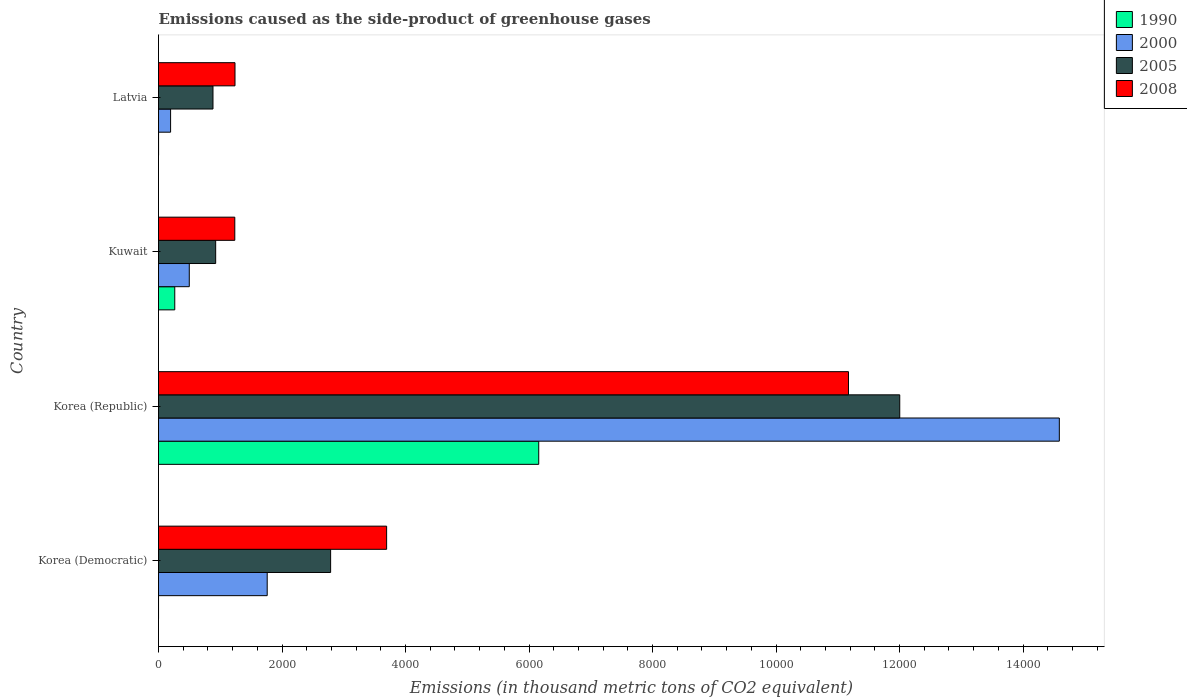How many groups of bars are there?
Ensure brevity in your answer.  4. Are the number of bars per tick equal to the number of legend labels?
Offer a terse response. Yes. Are the number of bars on each tick of the Y-axis equal?
Offer a terse response. Yes. What is the label of the 3rd group of bars from the top?
Keep it short and to the point. Korea (Republic). What is the emissions caused as the side-product of greenhouse gases in 1990 in Korea (Republic)?
Keep it short and to the point. 6157.2. Across all countries, what is the maximum emissions caused as the side-product of greenhouse gases in 2008?
Provide a succinct answer. 1.12e+04. Across all countries, what is the minimum emissions caused as the side-product of greenhouse gases in 2005?
Provide a short and direct response. 882.1. In which country was the emissions caused as the side-product of greenhouse gases in 2008 minimum?
Offer a very short reply. Kuwait. What is the total emissions caused as the side-product of greenhouse gases in 2000 in the graph?
Offer a very short reply. 1.70e+04. What is the difference between the emissions caused as the side-product of greenhouse gases in 2000 in Korea (Democratic) and that in Korea (Republic)?
Your response must be concise. -1.28e+04. What is the difference between the emissions caused as the side-product of greenhouse gases in 2000 in Kuwait and the emissions caused as the side-product of greenhouse gases in 2005 in Korea (Republic)?
Keep it short and to the point. -1.15e+04. What is the average emissions caused as the side-product of greenhouse gases in 2005 per country?
Make the answer very short. 4149.52. What is the difference between the emissions caused as the side-product of greenhouse gases in 2005 and emissions caused as the side-product of greenhouse gases in 2008 in Korea (Republic)?
Your answer should be very brief. 830.4. In how many countries, is the emissions caused as the side-product of greenhouse gases in 1990 greater than 10400 thousand metric tons?
Give a very brief answer. 0. What is the ratio of the emissions caused as the side-product of greenhouse gases in 1990 in Korea (Republic) to that in Latvia?
Give a very brief answer. 7696.5. Is the difference between the emissions caused as the side-product of greenhouse gases in 2005 in Korea (Democratic) and Korea (Republic) greater than the difference between the emissions caused as the side-product of greenhouse gases in 2008 in Korea (Democratic) and Korea (Republic)?
Keep it short and to the point. No. What is the difference between the highest and the second highest emissions caused as the side-product of greenhouse gases in 2005?
Offer a terse response. 9216.2. What is the difference between the highest and the lowest emissions caused as the side-product of greenhouse gases in 2000?
Keep it short and to the point. 1.44e+04. In how many countries, is the emissions caused as the side-product of greenhouse gases in 1990 greater than the average emissions caused as the side-product of greenhouse gases in 1990 taken over all countries?
Your answer should be compact. 1. Is the sum of the emissions caused as the side-product of greenhouse gases in 2005 in Korea (Republic) and Kuwait greater than the maximum emissions caused as the side-product of greenhouse gases in 1990 across all countries?
Offer a terse response. Yes. Is it the case that in every country, the sum of the emissions caused as the side-product of greenhouse gases in 2005 and emissions caused as the side-product of greenhouse gases in 2008 is greater than the sum of emissions caused as the side-product of greenhouse gases in 2000 and emissions caused as the side-product of greenhouse gases in 1990?
Your response must be concise. No. Is it the case that in every country, the sum of the emissions caused as the side-product of greenhouse gases in 1990 and emissions caused as the side-product of greenhouse gases in 2005 is greater than the emissions caused as the side-product of greenhouse gases in 2000?
Your answer should be very brief. Yes. Are all the bars in the graph horizontal?
Your answer should be compact. Yes. How many countries are there in the graph?
Give a very brief answer. 4. Does the graph contain grids?
Provide a succinct answer. No. How many legend labels are there?
Ensure brevity in your answer.  4. What is the title of the graph?
Offer a terse response. Emissions caused as the side-product of greenhouse gases. What is the label or title of the X-axis?
Your answer should be compact. Emissions (in thousand metric tons of CO2 equivalent). What is the label or title of the Y-axis?
Offer a terse response. Country. What is the Emissions (in thousand metric tons of CO2 equivalent) of 1990 in Korea (Democratic)?
Keep it short and to the point. 0.2. What is the Emissions (in thousand metric tons of CO2 equivalent) in 2000 in Korea (Democratic)?
Provide a short and direct response. 1760.1. What is the Emissions (in thousand metric tons of CO2 equivalent) of 2005 in Korea (Democratic)?
Provide a short and direct response. 2787.1. What is the Emissions (in thousand metric tons of CO2 equivalent) of 2008 in Korea (Democratic)?
Keep it short and to the point. 3693.8. What is the Emissions (in thousand metric tons of CO2 equivalent) in 1990 in Korea (Republic)?
Your answer should be very brief. 6157.2. What is the Emissions (in thousand metric tons of CO2 equivalent) of 2000 in Korea (Republic)?
Your answer should be compact. 1.46e+04. What is the Emissions (in thousand metric tons of CO2 equivalent) in 2005 in Korea (Republic)?
Keep it short and to the point. 1.20e+04. What is the Emissions (in thousand metric tons of CO2 equivalent) in 2008 in Korea (Republic)?
Your response must be concise. 1.12e+04. What is the Emissions (in thousand metric tons of CO2 equivalent) in 1990 in Kuwait?
Your answer should be very brief. 263.1. What is the Emissions (in thousand metric tons of CO2 equivalent) of 2000 in Kuwait?
Keep it short and to the point. 498.2. What is the Emissions (in thousand metric tons of CO2 equivalent) of 2005 in Kuwait?
Ensure brevity in your answer.  925.6. What is the Emissions (in thousand metric tons of CO2 equivalent) in 2008 in Kuwait?
Your answer should be compact. 1235.4. What is the Emissions (in thousand metric tons of CO2 equivalent) in 1990 in Latvia?
Your answer should be very brief. 0.8. What is the Emissions (in thousand metric tons of CO2 equivalent) in 2000 in Latvia?
Ensure brevity in your answer.  195.7. What is the Emissions (in thousand metric tons of CO2 equivalent) of 2005 in Latvia?
Your answer should be compact. 882.1. What is the Emissions (in thousand metric tons of CO2 equivalent) of 2008 in Latvia?
Your answer should be very brief. 1238.6. Across all countries, what is the maximum Emissions (in thousand metric tons of CO2 equivalent) in 1990?
Offer a terse response. 6157.2. Across all countries, what is the maximum Emissions (in thousand metric tons of CO2 equivalent) in 2000?
Make the answer very short. 1.46e+04. Across all countries, what is the maximum Emissions (in thousand metric tons of CO2 equivalent) of 2005?
Make the answer very short. 1.20e+04. Across all countries, what is the maximum Emissions (in thousand metric tons of CO2 equivalent) of 2008?
Ensure brevity in your answer.  1.12e+04. Across all countries, what is the minimum Emissions (in thousand metric tons of CO2 equivalent) of 2000?
Make the answer very short. 195.7. Across all countries, what is the minimum Emissions (in thousand metric tons of CO2 equivalent) of 2005?
Your answer should be compact. 882.1. Across all countries, what is the minimum Emissions (in thousand metric tons of CO2 equivalent) of 2008?
Offer a very short reply. 1235.4. What is the total Emissions (in thousand metric tons of CO2 equivalent) in 1990 in the graph?
Provide a short and direct response. 6421.3. What is the total Emissions (in thousand metric tons of CO2 equivalent) of 2000 in the graph?
Provide a succinct answer. 1.70e+04. What is the total Emissions (in thousand metric tons of CO2 equivalent) in 2005 in the graph?
Provide a succinct answer. 1.66e+04. What is the total Emissions (in thousand metric tons of CO2 equivalent) of 2008 in the graph?
Make the answer very short. 1.73e+04. What is the difference between the Emissions (in thousand metric tons of CO2 equivalent) in 1990 in Korea (Democratic) and that in Korea (Republic)?
Ensure brevity in your answer.  -6157. What is the difference between the Emissions (in thousand metric tons of CO2 equivalent) in 2000 in Korea (Democratic) and that in Korea (Republic)?
Ensure brevity in your answer.  -1.28e+04. What is the difference between the Emissions (in thousand metric tons of CO2 equivalent) in 2005 in Korea (Democratic) and that in Korea (Republic)?
Your answer should be very brief. -9216.2. What is the difference between the Emissions (in thousand metric tons of CO2 equivalent) of 2008 in Korea (Democratic) and that in Korea (Republic)?
Your answer should be very brief. -7479.1. What is the difference between the Emissions (in thousand metric tons of CO2 equivalent) of 1990 in Korea (Democratic) and that in Kuwait?
Offer a terse response. -262.9. What is the difference between the Emissions (in thousand metric tons of CO2 equivalent) in 2000 in Korea (Democratic) and that in Kuwait?
Offer a terse response. 1261.9. What is the difference between the Emissions (in thousand metric tons of CO2 equivalent) of 2005 in Korea (Democratic) and that in Kuwait?
Offer a very short reply. 1861.5. What is the difference between the Emissions (in thousand metric tons of CO2 equivalent) in 2008 in Korea (Democratic) and that in Kuwait?
Your answer should be compact. 2458.4. What is the difference between the Emissions (in thousand metric tons of CO2 equivalent) in 1990 in Korea (Democratic) and that in Latvia?
Provide a short and direct response. -0.6. What is the difference between the Emissions (in thousand metric tons of CO2 equivalent) of 2000 in Korea (Democratic) and that in Latvia?
Your answer should be very brief. 1564.4. What is the difference between the Emissions (in thousand metric tons of CO2 equivalent) of 2005 in Korea (Democratic) and that in Latvia?
Your response must be concise. 1905. What is the difference between the Emissions (in thousand metric tons of CO2 equivalent) in 2008 in Korea (Democratic) and that in Latvia?
Provide a short and direct response. 2455.2. What is the difference between the Emissions (in thousand metric tons of CO2 equivalent) of 1990 in Korea (Republic) and that in Kuwait?
Your response must be concise. 5894.1. What is the difference between the Emissions (in thousand metric tons of CO2 equivalent) in 2000 in Korea (Republic) and that in Kuwait?
Your answer should be very brief. 1.41e+04. What is the difference between the Emissions (in thousand metric tons of CO2 equivalent) in 2005 in Korea (Republic) and that in Kuwait?
Offer a terse response. 1.11e+04. What is the difference between the Emissions (in thousand metric tons of CO2 equivalent) of 2008 in Korea (Republic) and that in Kuwait?
Your answer should be compact. 9937.5. What is the difference between the Emissions (in thousand metric tons of CO2 equivalent) of 1990 in Korea (Republic) and that in Latvia?
Ensure brevity in your answer.  6156.4. What is the difference between the Emissions (in thousand metric tons of CO2 equivalent) of 2000 in Korea (Republic) and that in Latvia?
Give a very brief answer. 1.44e+04. What is the difference between the Emissions (in thousand metric tons of CO2 equivalent) in 2005 in Korea (Republic) and that in Latvia?
Offer a terse response. 1.11e+04. What is the difference between the Emissions (in thousand metric tons of CO2 equivalent) of 2008 in Korea (Republic) and that in Latvia?
Provide a succinct answer. 9934.3. What is the difference between the Emissions (in thousand metric tons of CO2 equivalent) in 1990 in Kuwait and that in Latvia?
Keep it short and to the point. 262.3. What is the difference between the Emissions (in thousand metric tons of CO2 equivalent) in 2000 in Kuwait and that in Latvia?
Your answer should be compact. 302.5. What is the difference between the Emissions (in thousand metric tons of CO2 equivalent) in 2005 in Kuwait and that in Latvia?
Offer a very short reply. 43.5. What is the difference between the Emissions (in thousand metric tons of CO2 equivalent) in 1990 in Korea (Democratic) and the Emissions (in thousand metric tons of CO2 equivalent) in 2000 in Korea (Republic)?
Your answer should be compact. -1.46e+04. What is the difference between the Emissions (in thousand metric tons of CO2 equivalent) of 1990 in Korea (Democratic) and the Emissions (in thousand metric tons of CO2 equivalent) of 2005 in Korea (Republic)?
Ensure brevity in your answer.  -1.20e+04. What is the difference between the Emissions (in thousand metric tons of CO2 equivalent) of 1990 in Korea (Democratic) and the Emissions (in thousand metric tons of CO2 equivalent) of 2008 in Korea (Republic)?
Provide a short and direct response. -1.12e+04. What is the difference between the Emissions (in thousand metric tons of CO2 equivalent) of 2000 in Korea (Democratic) and the Emissions (in thousand metric tons of CO2 equivalent) of 2005 in Korea (Republic)?
Ensure brevity in your answer.  -1.02e+04. What is the difference between the Emissions (in thousand metric tons of CO2 equivalent) of 2000 in Korea (Democratic) and the Emissions (in thousand metric tons of CO2 equivalent) of 2008 in Korea (Republic)?
Provide a succinct answer. -9412.8. What is the difference between the Emissions (in thousand metric tons of CO2 equivalent) in 2005 in Korea (Democratic) and the Emissions (in thousand metric tons of CO2 equivalent) in 2008 in Korea (Republic)?
Offer a terse response. -8385.8. What is the difference between the Emissions (in thousand metric tons of CO2 equivalent) in 1990 in Korea (Democratic) and the Emissions (in thousand metric tons of CO2 equivalent) in 2000 in Kuwait?
Keep it short and to the point. -498. What is the difference between the Emissions (in thousand metric tons of CO2 equivalent) in 1990 in Korea (Democratic) and the Emissions (in thousand metric tons of CO2 equivalent) in 2005 in Kuwait?
Offer a terse response. -925.4. What is the difference between the Emissions (in thousand metric tons of CO2 equivalent) in 1990 in Korea (Democratic) and the Emissions (in thousand metric tons of CO2 equivalent) in 2008 in Kuwait?
Your answer should be very brief. -1235.2. What is the difference between the Emissions (in thousand metric tons of CO2 equivalent) in 2000 in Korea (Democratic) and the Emissions (in thousand metric tons of CO2 equivalent) in 2005 in Kuwait?
Offer a very short reply. 834.5. What is the difference between the Emissions (in thousand metric tons of CO2 equivalent) in 2000 in Korea (Democratic) and the Emissions (in thousand metric tons of CO2 equivalent) in 2008 in Kuwait?
Your answer should be compact. 524.7. What is the difference between the Emissions (in thousand metric tons of CO2 equivalent) of 2005 in Korea (Democratic) and the Emissions (in thousand metric tons of CO2 equivalent) of 2008 in Kuwait?
Offer a terse response. 1551.7. What is the difference between the Emissions (in thousand metric tons of CO2 equivalent) in 1990 in Korea (Democratic) and the Emissions (in thousand metric tons of CO2 equivalent) in 2000 in Latvia?
Provide a succinct answer. -195.5. What is the difference between the Emissions (in thousand metric tons of CO2 equivalent) in 1990 in Korea (Democratic) and the Emissions (in thousand metric tons of CO2 equivalent) in 2005 in Latvia?
Offer a terse response. -881.9. What is the difference between the Emissions (in thousand metric tons of CO2 equivalent) in 1990 in Korea (Democratic) and the Emissions (in thousand metric tons of CO2 equivalent) in 2008 in Latvia?
Offer a very short reply. -1238.4. What is the difference between the Emissions (in thousand metric tons of CO2 equivalent) of 2000 in Korea (Democratic) and the Emissions (in thousand metric tons of CO2 equivalent) of 2005 in Latvia?
Provide a short and direct response. 878. What is the difference between the Emissions (in thousand metric tons of CO2 equivalent) of 2000 in Korea (Democratic) and the Emissions (in thousand metric tons of CO2 equivalent) of 2008 in Latvia?
Offer a terse response. 521.5. What is the difference between the Emissions (in thousand metric tons of CO2 equivalent) in 2005 in Korea (Democratic) and the Emissions (in thousand metric tons of CO2 equivalent) in 2008 in Latvia?
Your response must be concise. 1548.5. What is the difference between the Emissions (in thousand metric tons of CO2 equivalent) of 1990 in Korea (Republic) and the Emissions (in thousand metric tons of CO2 equivalent) of 2000 in Kuwait?
Give a very brief answer. 5659. What is the difference between the Emissions (in thousand metric tons of CO2 equivalent) in 1990 in Korea (Republic) and the Emissions (in thousand metric tons of CO2 equivalent) in 2005 in Kuwait?
Offer a terse response. 5231.6. What is the difference between the Emissions (in thousand metric tons of CO2 equivalent) in 1990 in Korea (Republic) and the Emissions (in thousand metric tons of CO2 equivalent) in 2008 in Kuwait?
Your response must be concise. 4921.8. What is the difference between the Emissions (in thousand metric tons of CO2 equivalent) of 2000 in Korea (Republic) and the Emissions (in thousand metric tons of CO2 equivalent) of 2005 in Kuwait?
Make the answer very short. 1.37e+04. What is the difference between the Emissions (in thousand metric tons of CO2 equivalent) in 2000 in Korea (Republic) and the Emissions (in thousand metric tons of CO2 equivalent) in 2008 in Kuwait?
Your answer should be very brief. 1.34e+04. What is the difference between the Emissions (in thousand metric tons of CO2 equivalent) of 2005 in Korea (Republic) and the Emissions (in thousand metric tons of CO2 equivalent) of 2008 in Kuwait?
Give a very brief answer. 1.08e+04. What is the difference between the Emissions (in thousand metric tons of CO2 equivalent) of 1990 in Korea (Republic) and the Emissions (in thousand metric tons of CO2 equivalent) of 2000 in Latvia?
Provide a succinct answer. 5961.5. What is the difference between the Emissions (in thousand metric tons of CO2 equivalent) of 1990 in Korea (Republic) and the Emissions (in thousand metric tons of CO2 equivalent) of 2005 in Latvia?
Ensure brevity in your answer.  5275.1. What is the difference between the Emissions (in thousand metric tons of CO2 equivalent) of 1990 in Korea (Republic) and the Emissions (in thousand metric tons of CO2 equivalent) of 2008 in Latvia?
Your response must be concise. 4918.6. What is the difference between the Emissions (in thousand metric tons of CO2 equivalent) of 2000 in Korea (Republic) and the Emissions (in thousand metric tons of CO2 equivalent) of 2005 in Latvia?
Give a very brief answer. 1.37e+04. What is the difference between the Emissions (in thousand metric tons of CO2 equivalent) in 2000 in Korea (Republic) and the Emissions (in thousand metric tons of CO2 equivalent) in 2008 in Latvia?
Offer a very short reply. 1.33e+04. What is the difference between the Emissions (in thousand metric tons of CO2 equivalent) in 2005 in Korea (Republic) and the Emissions (in thousand metric tons of CO2 equivalent) in 2008 in Latvia?
Provide a succinct answer. 1.08e+04. What is the difference between the Emissions (in thousand metric tons of CO2 equivalent) in 1990 in Kuwait and the Emissions (in thousand metric tons of CO2 equivalent) in 2000 in Latvia?
Keep it short and to the point. 67.4. What is the difference between the Emissions (in thousand metric tons of CO2 equivalent) of 1990 in Kuwait and the Emissions (in thousand metric tons of CO2 equivalent) of 2005 in Latvia?
Your answer should be very brief. -619. What is the difference between the Emissions (in thousand metric tons of CO2 equivalent) in 1990 in Kuwait and the Emissions (in thousand metric tons of CO2 equivalent) in 2008 in Latvia?
Keep it short and to the point. -975.5. What is the difference between the Emissions (in thousand metric tons of CO2 equivalent) in 2000 in Kuwait and the Emissions (in thousand metric tons of CO2 equivalent) in 2005 in Latvia?
Your answer should be very brief. -383.9. What is the difference between the Emissions (in thousand metric tons of CO2 equivalent) of 2000 in Kuwait and the Emissions (in thousand metric tons of CO2 equivalent) of 2008 in Latvia?
Offer a terse response. -740.4. What is the difference between the Emissions (in thousand metric tons of CO2 equivalent) in 2005 in Kuwait and the Emissions (in thousand metric tons of CO2 equivalent) in 2008 in Latvia?
Make the answer very short. -313. What is the average Emissions (in thousand metric tons of CO2 equivalent) of 1990 per country?
Make the answer very short. 1605.33. What is the average Emissions (in thousand metric tons of CO2 equivalent) in 2000 per country?
Offer a terse response. 4260.32. What is the average Emissions (in thousand metric tons of CO2 equivalent) in 2005 per country?
Your response must be concise. 4149.52. What is the average Emissions (in thousand metric tons of CO2 equivalent) in 2008 per country?
Ensure brevity in your answer.  4335.18. What is the difference between the Emissions (in thousand metric tons of CO2 equivalent) of 1990 and Emissions (in thousand metric tons of CO2 equivalent) of 2000 in Korea (Democratic)?
Keep it short and to the point. -1759.9. What is the difference between the Emissions (in thousand metric tons of CO2 equivalent) of 1990 and Emissions (in thousand metric tons of CO2 equivalent) of 2005 in Korea (Democratic)?
Give a very brief answer. -2786.9. What is the difference between the Emissions (in thousand metric tons of CO2 equivalent) in 1990 and Emissions (in thousand metric tons of CO2 equivalent) in 2008 in Korea (Democratic)?
Give a very brief answer. -3693.6. What is the difference between the Emissions (in thousand metric tons of CO2 equivalent) in 2000 and Emissions (in thousand metric tons of CO2 equivalent) in 2005 in Korea (Democratic)?
Offer a very short reply. -1027. What is the difference between the Emissions (in thousand metric tons of CO2 equivalent) of 2000 and Emissions (in thousand metric tons of CO2 equivalent) of 2008 in Korea (Democratic)?
Offer a very short reply. -1933.7. What is the difference between the Emissions (in thousand metric tons of CO2 equivalent) of 2005 and Emissions (in thousand metric tons of CO2 equivalent) of 2008 in Korea (Democratic)?
Your answer should be very brief. -906.7. What is the difference between the Emissions (in thousand metric tons of CO2 equivalent) in 1990 and Emissions (in thousand metric tons of CO2 equivalent) in 2000 in Korea (Republic)?
Provide a succinct answer. -8430.1. What is the difference between the Emissions (in thousand metric tons of CO2 equivalent) in 1990 and Emissions (in thousand metric tons of CO2 equivalent) in 2005 in Korea (Republic)?
Your answer should be compact. -5846.1. What is the difference between the Emissions (in thousand metric tons of CO2 equivalent) of 1990 and Emissions (in thousand metric tons of CO2 equivalent) of 2008 in Korea (Republic)?
Give a very brief answer. -5015.7. What is the difference between the Emissions (in thousand metric tons of CO2 equivalent) in 2000 and Emissions (in thousand metric tons of CO2 equivalent) in 2005 in Korea (Republic)?
Offer a very short reply. 2584. What is the difference between the Emissions (in thousand metric tons of CO2 equivalent) of 2000 and Emissions (in thousand metric tons of CO2 equivalent) of 2008 in Korea (Republic)?
Your answer should be compact. 3414.4. What is the difference between the Emissions (in thousand metric tons of CO2 equivalent) in 2005 and Emissions (in thousand metric tons of CO2 equivalent) in 2008 in Korea (Republic)?
Provide a short and direct response. 830.4. What is the difference between the Emissions (in thousand metric tons of CO2 equivalent) of 1990 and Emissions (in thousand metric tons of CO2 equivalent) of 2000 in Kuwait?
Ensure brevity in your answer.  -235.1. What is the difference between the Emissions (in thousand metric tons of CO2 equivalent) of 1990 and Emissions (in thousand metric tons of CO2 equivalent) of 2005 in Kuwait?
Offer a terse response. -662.5. What is the difference between the Emissions (in thousand metric tons of CO2 equivalent) in 1990 and Emissions (in thousand metric tons of CO2 equivalent) in 2008 in Kuwait?
Ensure brevity in your answer.  -972.3. What is the difference between the Emissions (in thousand metric tons of CO2 equivalent) of 2000 and Emissions (in thousand metric tons of CO2 equivalent) of 2005 in Kuwait?
Your answer should be compact. -427.4. What is the difference between the Emissions (in thousand metric tons of CO2 equivalent) of 2000 and Emissions (in thousand metric tons of CO2 equivalent) of 2008 in Kuwait?
Provide a succinct answer. -737.2. What is the difference between the Emissions (in thousand metric tons of CO2 equivalent) of 2005 and Emissions (in thousand metric tons of CO2 equivalent) of 2008 in Kuwait?
Your answer should be very brief. -309.8. What is the difference between the Emissions (in thousand metric tons of CO2 equivalent) in 1990 and Emissions (in thousand metric tons of CO2 equivalent) in 2000 in Latvia?
Offer a terse response. -194.9. What is the difference between the Emissions (in thousand metric tons of CO2 equivalent) of 1990 and Emissions (in thousand metric tons of CO2 equivalent) of 2005 in Latvia?
Your answer should be very brief. -881.3. What is the difference between the Emissions (in thousand metric tons of CO2 equivalent) of 1990 and Emissions (in thousand metric tons of CO2 equivalent) of 2008 in Latvia?
Give a very brief answer. -1237.8. What is the difference between the Emissions (in thousand metric tons of CO2 equivalent) in 2000 and Emissions (in thousand metric tons of CO2 equivalent) in 2005 in Latvia?
Offer a terse response. -686.4. What is the difference between the Emissions (in thousand metric tons of CO2 equivalent) in 2000 and Emissions (in thousand metric tons of CO2 equivalent) in 2008 in Latvia?
Offer a terse response. -1042.9. What is the difference between the Emissions (in thousand metric tons of CO2 equivalent) in 2005 and Emissions (in thousand metric tons of CO2 equivalent) in 2008 in Latvia?
Provide a short and direct response. -356.5. What is the ratio of the Emissions (in thousand metric tons of CO2 equivalent) of 1990 in Korea (Democratic) to that in Korea (Republic)?
Ensure brevity in your answer.  0. What is the ratio of the Emissions (in thousand metric tons of CO2 equivalent) in 2000 in Korea (Democratic) to that in Korea (Republic)?
Provide a succinct answer. 0.12. What is the ratio of the Emissions (in thousand metric tons of CO2 equivalent) of 2005 in Korea (Democratic) to that in Korea (Republic)?
Offer a very short reply. 0.23. What is the ratio of the Emissions (in thousand metric tons of CO2 equivalent) in 2008 in Korea (Democratic) to that in Korea (Republic)?
Your answer should be compact. 0.33. What is the ratio of the Emissions (in thousand metric tons of CO2 equivalent) in 1990 in Korea (Democratic) to that in Kuwait?
Offer a very short reply. 0. What is the ratio of the Emissions (in thousand metric tons of CO2 equivalent) in 2000 in Korea (Democratic) to that in Kuwait?
Give a very brief answer. 3.53. What is the ratio of the Emissions (in thousand metric tons of CO2 equivalent) of 2005 in Korea (Democratic) to that in Kuwait?
Keep it short and to the point. 3.01. What is the ratio of the Emissions (in thousand metric tons of CO2 equivalent) of 2008 in Korea (Democratic) to that in Kuwait?
Offer a terse response. 2.99. What is the ratio of the Emissions (in thousand metric tons of CO2 equivalent) of 1990 in Korea (Democratic) to that in Latvia?
Your answer should be very brief. 0.25. What is the ratio of the Emissions (in thousand metric tons of CO2 equivalent) of 2000 in Korea (Democratic) to that in Latvia?
Offer a very short reply. 8.99. What is the ratio of the Emissions (in thousand metric tons of CO2 equivalent) of 2005 in Korea (Democratic) to that in Latvia?
Provide a short and direct response. 3.16. What is the ratio of the Emissions (in thousand metric tons of CO2 equivalent) in 2008 in Korea (Democratic) to that in Latvia?
Your answer should be very brief. 2.98. What is the ratio of the Emissions (in thousand metric tons of CO2 equivalent) of 1990 in Korea (Republic) to that in Kuwait?
Provide a short and direct response. 23.4. What is the ratio of the Emissions (in thousand metric tons of CO2 equivalent) in 2000 in Korea (Republic) to that in Kuwait?
Your answer should be compact. 29.28. What is the ratio of the Emissions (in thousand metric tons of CO2 equivalent) in 2005 in Korea (Republic) to that in Kuwait?
Ensure brevity in your answer.  12.97. What is the ratio of the Emissions (in thousand metric tons of CO2 equivalent) in 2008 in Korea (Republic) to that in Kuwait?
Your answer should be compact. 9.04. What is the ratio of the Emissions (in thousand metric tons of CO2 equivalent) in 1990 in Korea (Republic) to that in Latvia?
Ensure brevity in your answer.  7696.5. What is the ratio of the Emissions (in thousand metric tons of CO2 equivalent) in 2000 in Korea (Republic) to that in Latvia?
Ensure brevity in your answer.  74.54. What is the ratio of the Emissions (in thousand metric tons of CO2 equivalent) of 2005 in Korea (Republic) to that in Latvia?
Make the answer very short. 13.61. What is the ratio of the Emissions (in thousand metric tons of CO2 equivalent) of 2008 in Korea (Republic) to that in Latvia?
Give a very brief answer. 9.02. What is the ratio of the Emissions (in thousand metric tons of CO2 equivalent) of 1990 in Kuwait to that in Latvia?
Provide a succinct answer. 328.88. What is the ratio of the Emissions (in thousand metric tons of CO2 equivalent) of 2000 in Kuwait to that in Latvia?
Provide a short and direct response. 2.55. What is the ratio of the Emissions (in thousand metric tons of CO2 equivalent) of 2005 in Kuwait to that in Latvia?
Provide a short and direct response. 1.05. What is the ratio of the Emissions (in thousand metric tons of CO2 equivalent) in 2008 in Kuwait to that in Latvia?
Your answer should be compact. 1. What is the difference between the highest and the second highest Emissions (in thousand metric tons of CO2 equivalent) in 1990?
Your answer should be compact. 5894.1. What is the difference between the highest and the second highest Emissions (in thousand metric tons of CO2 equivalent) of 2000?
Your answer should be very brief. 1.28e+04. What is the difference between the highest and the second highest Emissions (in thousand metric tons of CO2 equivalent) of 2005?
Offer a terse response. 9216.2. What is the difference between the highest and the second highest Emissions (in thousand metric tons of CO2 equivalent) in 2008?
Keep it short and to the point. 7479.1. What is the difference between the highest and the lowest Emissions (in thousand metric tons of CO2 equivalent) in 1990?
Your answer should be very brief. 6157. What is the difference between the highest and the lowest Emissions (in thousand metric tons of CO2 equivalent) in 2000?
Your response must be concise. 1.44e+04. What is the difference between the highest and the lowest Emissions (in thousand metric tons of CO2 equivalent) in 2005?
Your response must be concise. 1.11e+04. What is the difference between the highest and the lowest Emissions (in thousand metric tons of CO2 equivalent) in 2008?
Keep it short and to the point. 9937.5. 